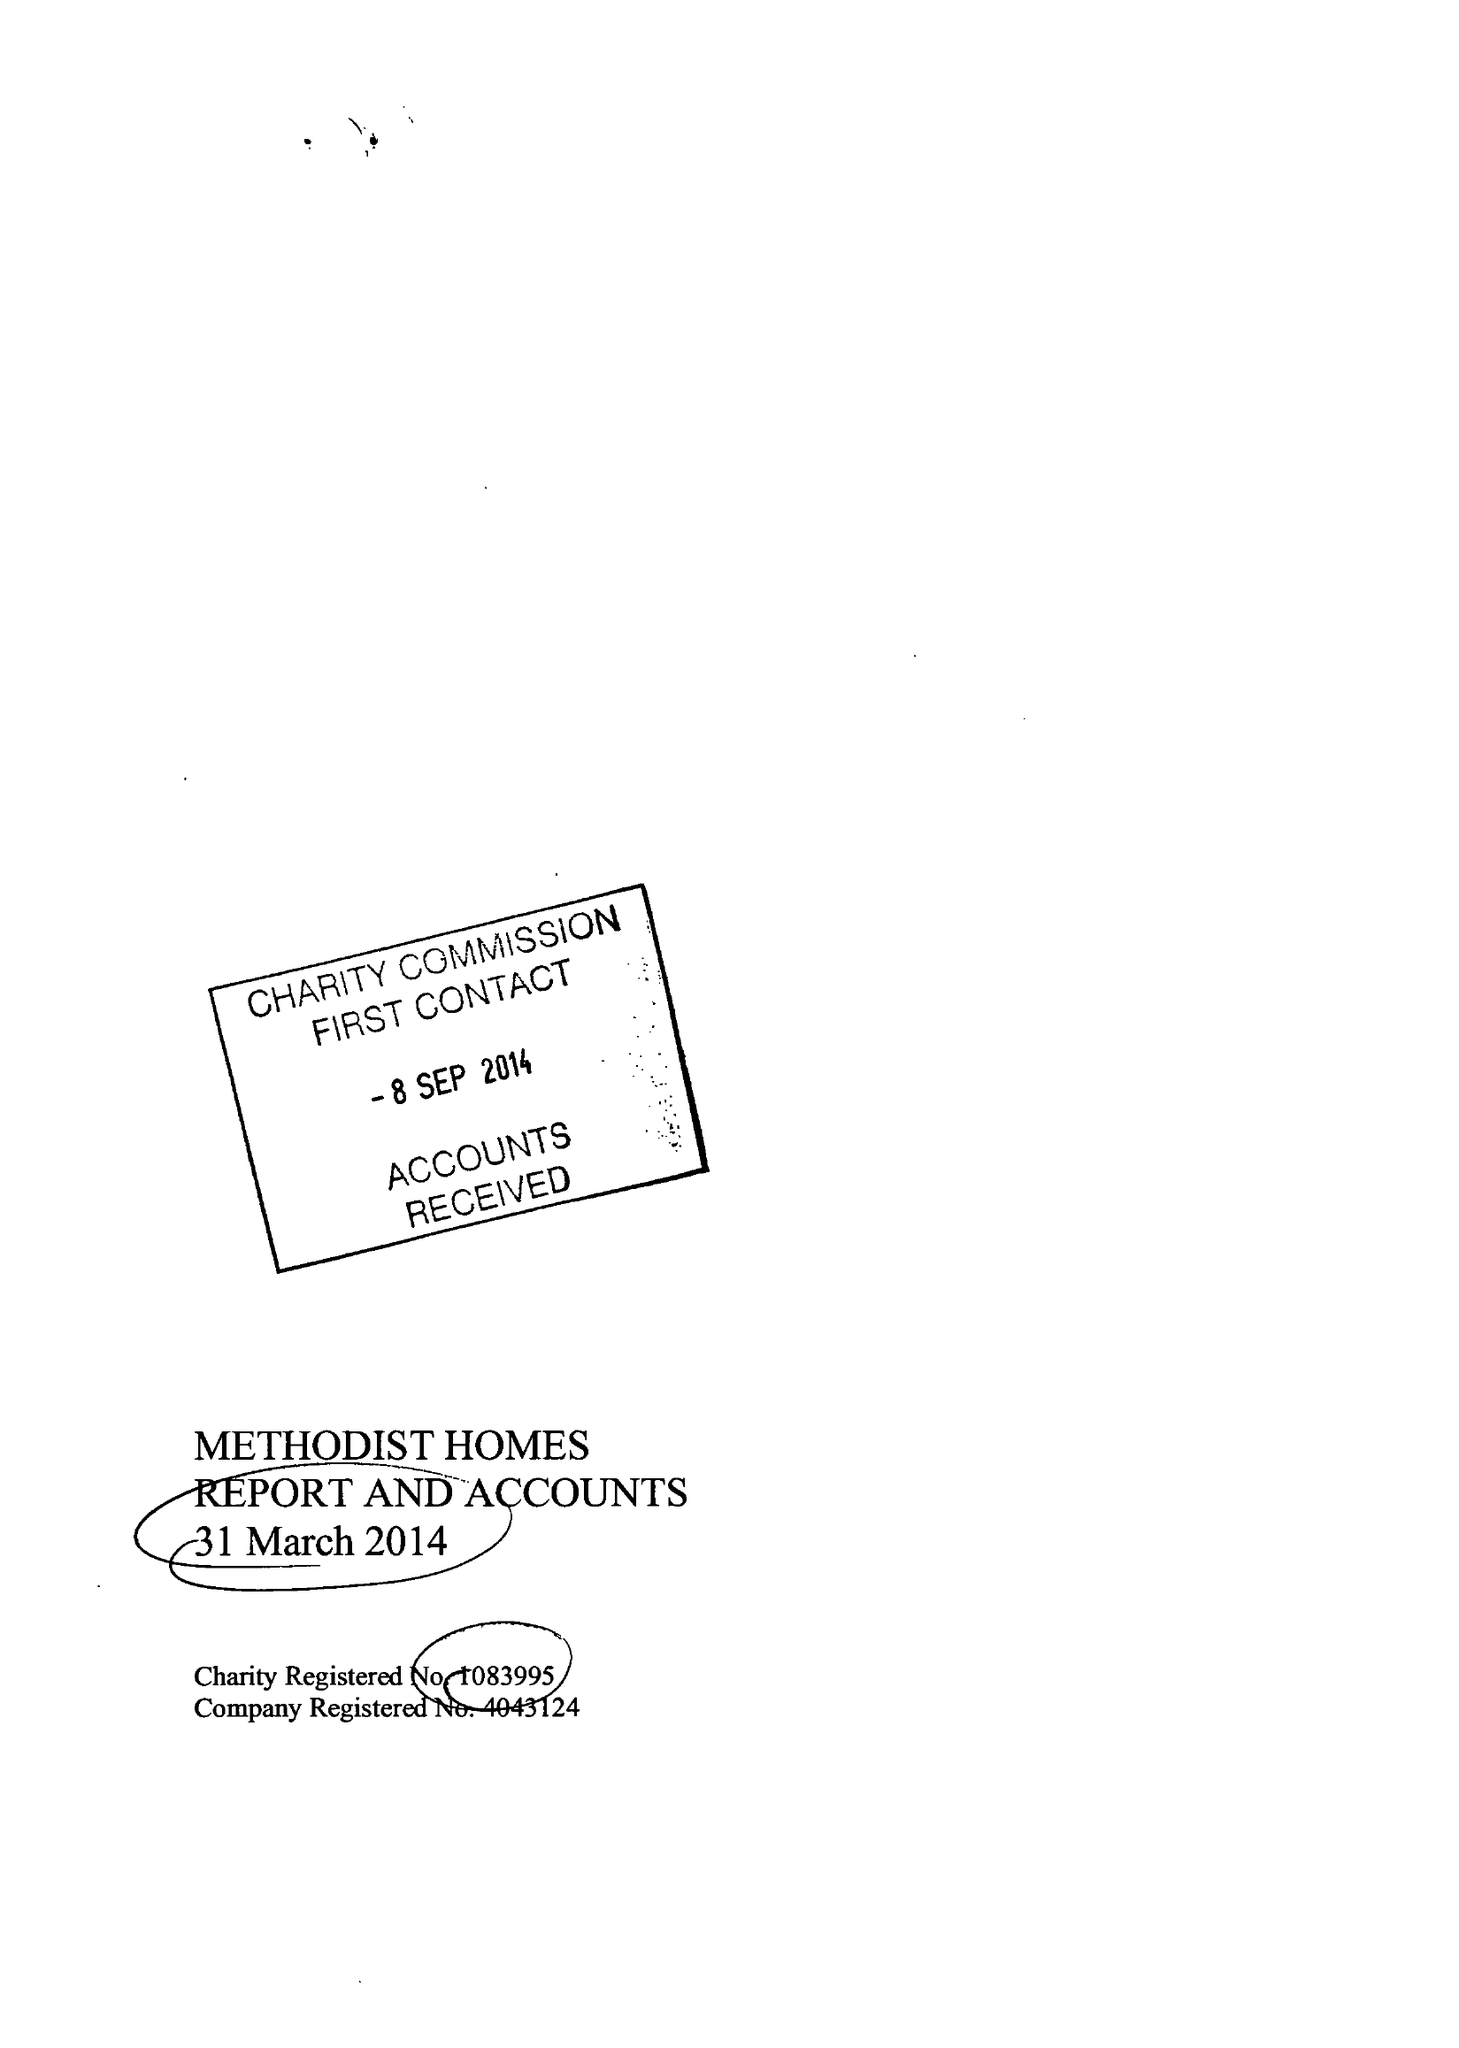What is the value for the address__postcode?
Answer the question using a single word or phrase. DE1 2EQ 